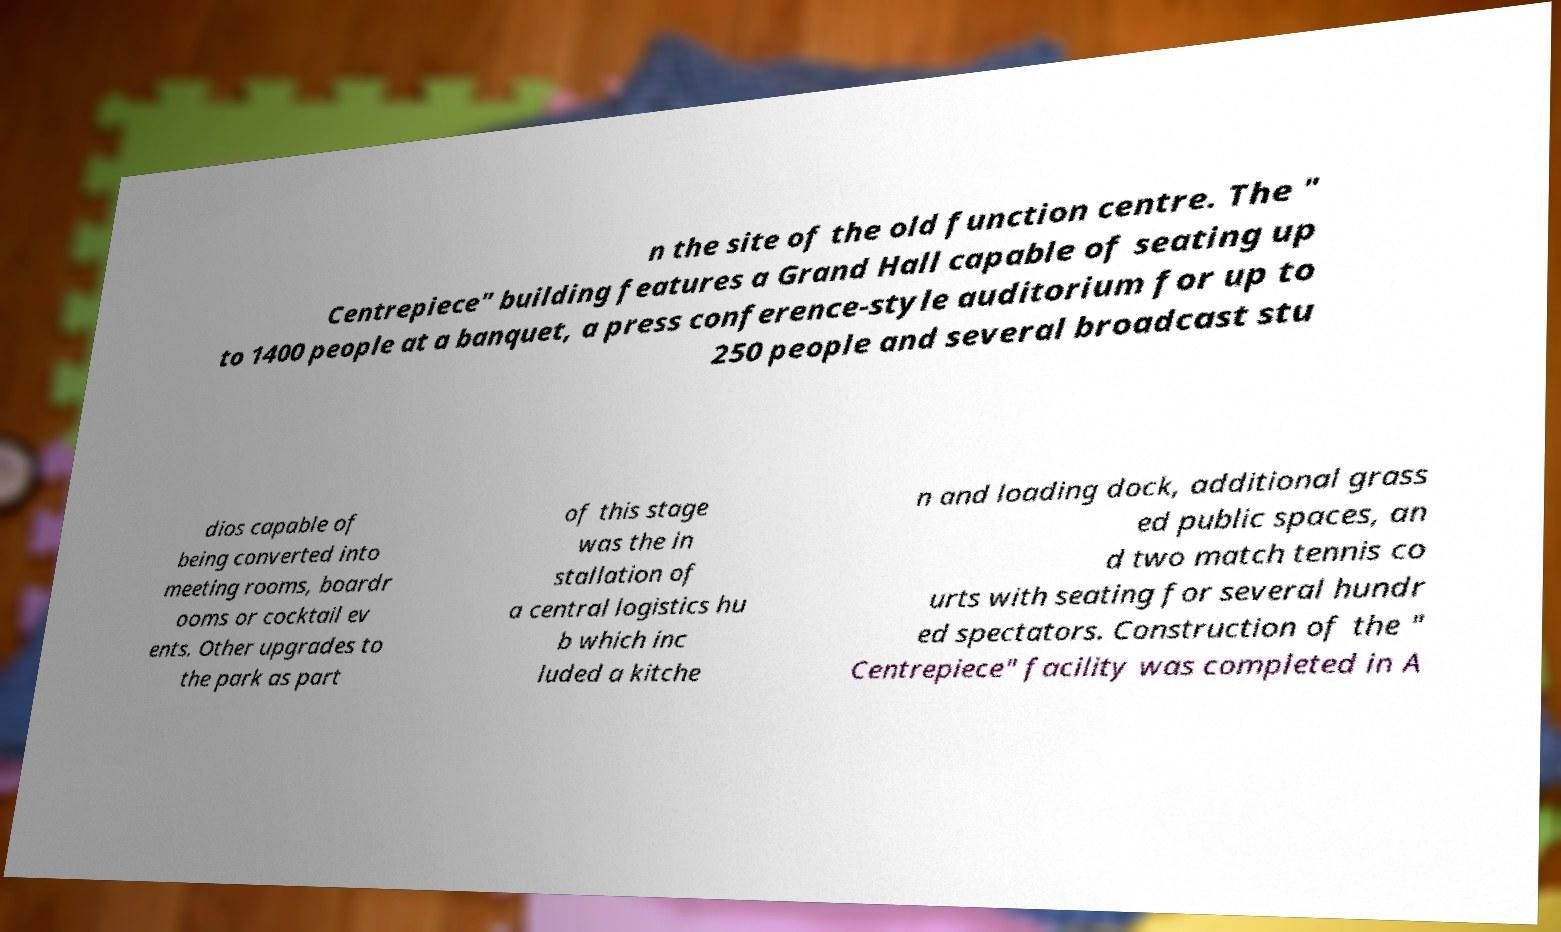There's text embedded in this image that I need extracted. Can you transcribe it verbatim? n the site of the old function centre. The " Centrepiece" building features a Grand Hall capable of seating up to 1400 people at a banquet, a press conference-style auditorium for up to 250 people and several broadcast stu dios capable of being converted into meeting rooms, boardr ooms or cocktail ev ents. Other upgrades to the park as part of this stage was the in stallation of a central logistics hu b which inc luded a kitche n and loading dock, additional grass ed public spaces, an d two match tennis co urts with seating for several hundr ed spectators. Construction of the " Centrepiece" facility was completed in A 